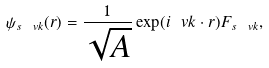<formula> <loc_0><loc_0><loc_500><loc_500>\psi _ { s \ v k } ( { r } ) = \frac { 1 } { \sqrt { A } } \exp ( i \ v k \cdot { r } ) F _ { s \ v k } ,</formula> 